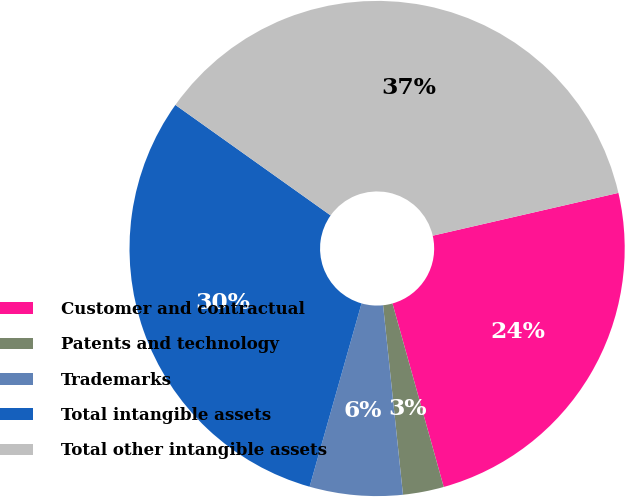<chart> <loc_0><loc_0><loc_500><loc_500><pie_chart><fcel>Customer and contractual<fcel>Patents and technology<fcel>Trademarks<fcel>Total intangible assets<fcel>Total other intangible assets<nl><fcel>24.27%<fcel>2.67%<fcel>6.06%<fcel>30.45%<fcel>36.55%<nl></chart> 